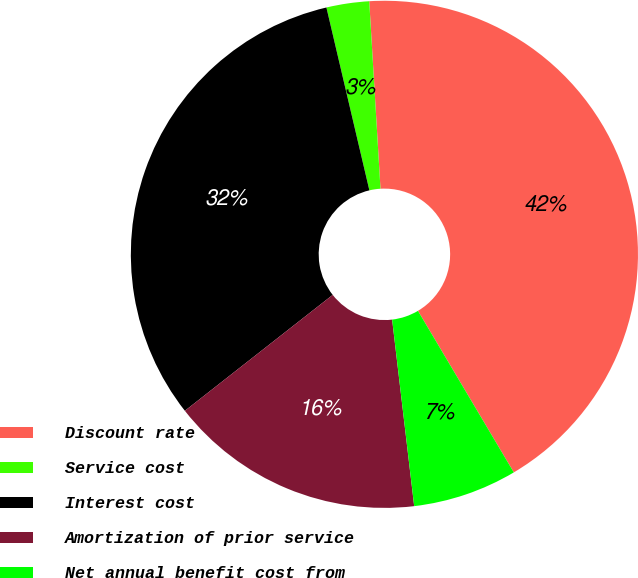Convert chart to OTSL. <chart><loc_0><loc_0><loc_500><loc_500><pie_chart><fcel>Discount rate<fcel>Service cost<fcel>Interest cost<fcel>Amortization of prior service<fcel>Net annual benefit cost from<nl><fcel>42.43%<fcel>2.72%<fcel>31.91%<fcel>16.29%<fcel>6.65%<nl></chart> 